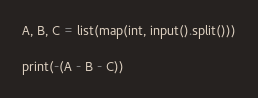Convert code to text. <code><loc_0><loc_0><loc_500><loc_500><_Python_>A, B, C = list(map(int, input().split()))

print(-(A - B - C))
</code> 